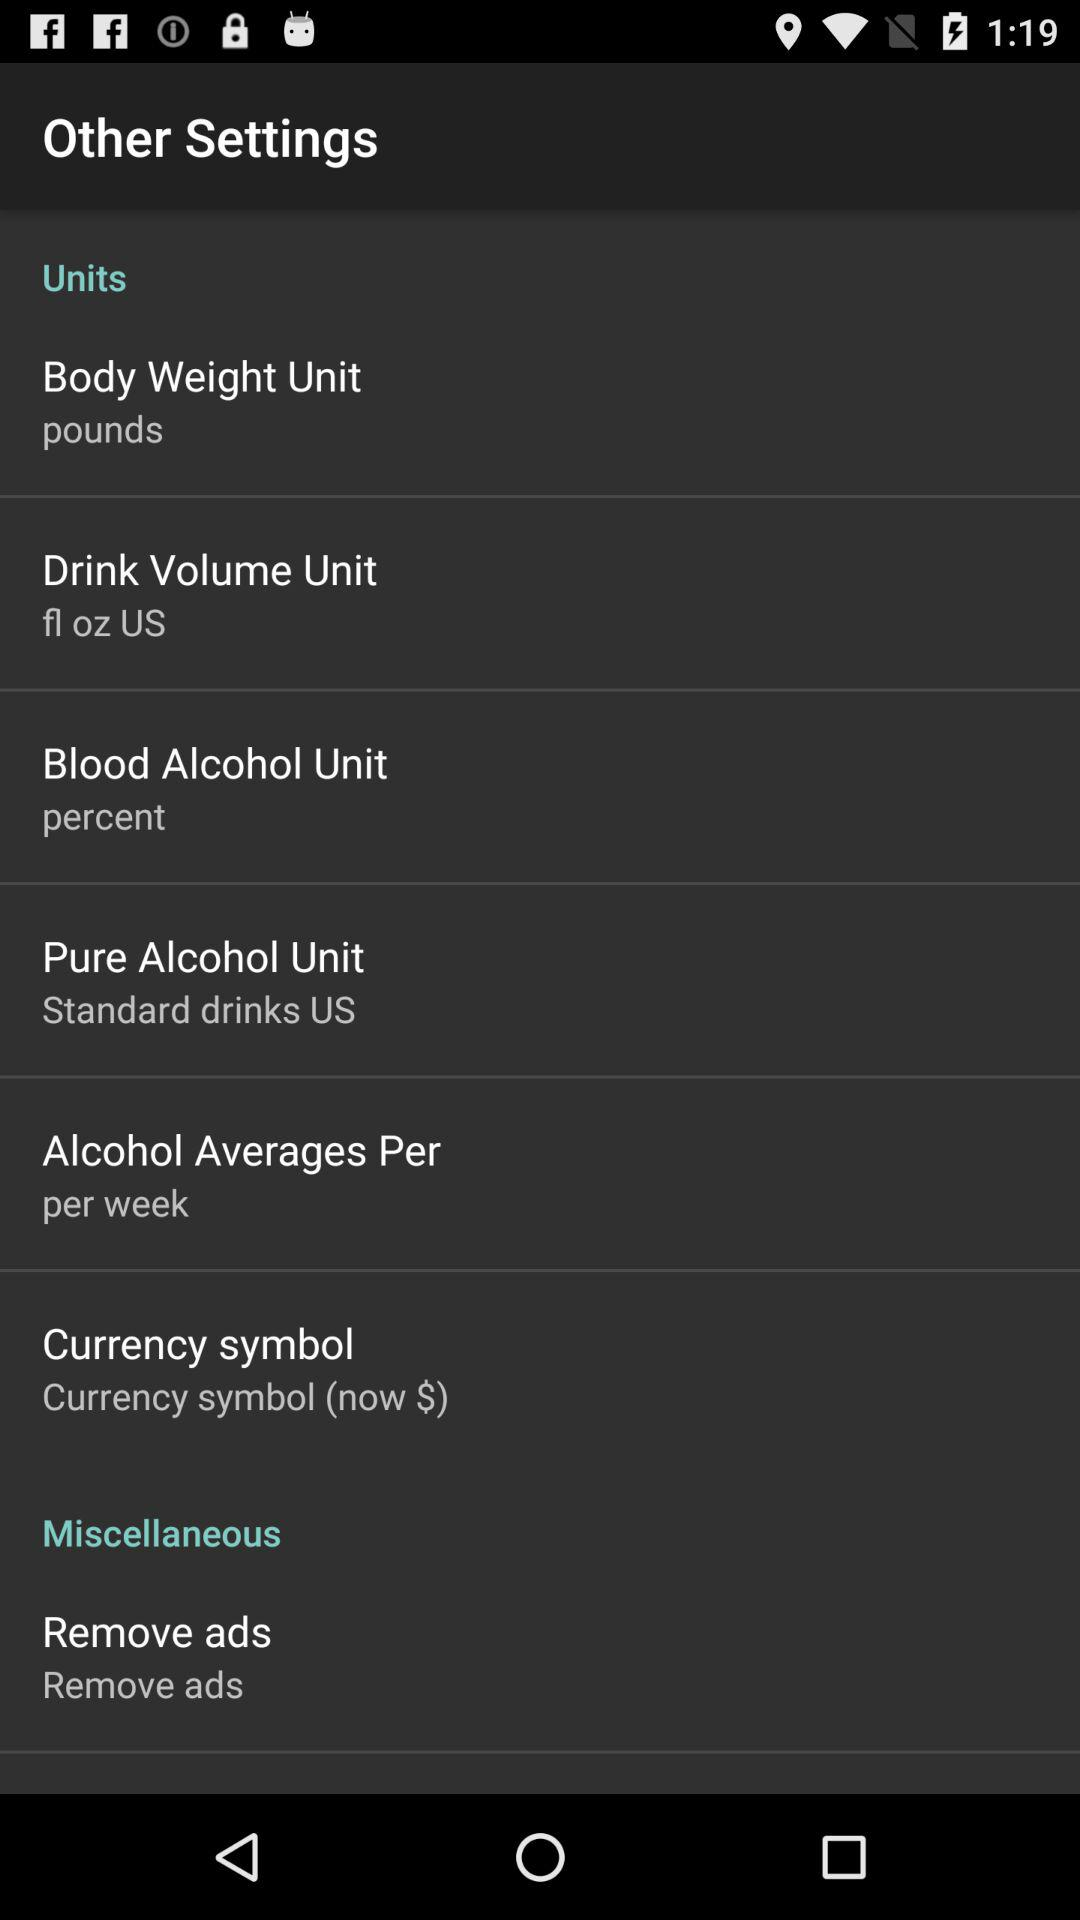Which currency is shown? The shown currency is $. 